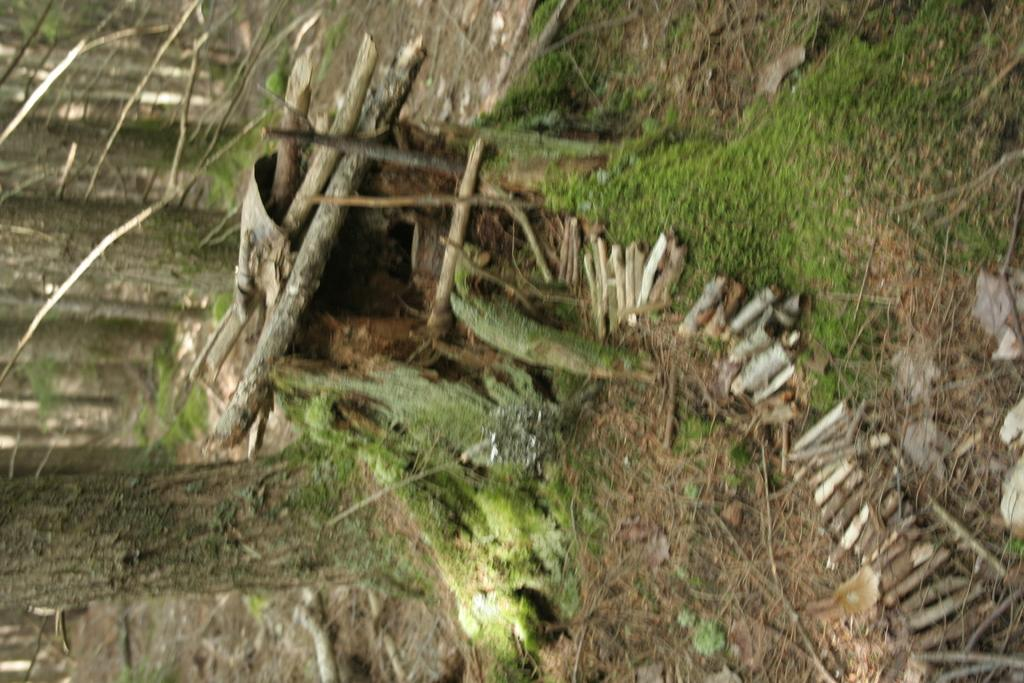What type of objects are made of wood in the image? There are wooden sticks in the image. What type of natural environment is visible in the image? There is grass visible in the image. What part of a tree can be seen in the image? There are tree trunks in the image. Is there a volcano visible in the image? No, there is no volcano present in the image. What type of expansion can be seen happening to the wooden sticks in the image? The wooden sticks do not appear to be expanding in the image; they are stationary. 